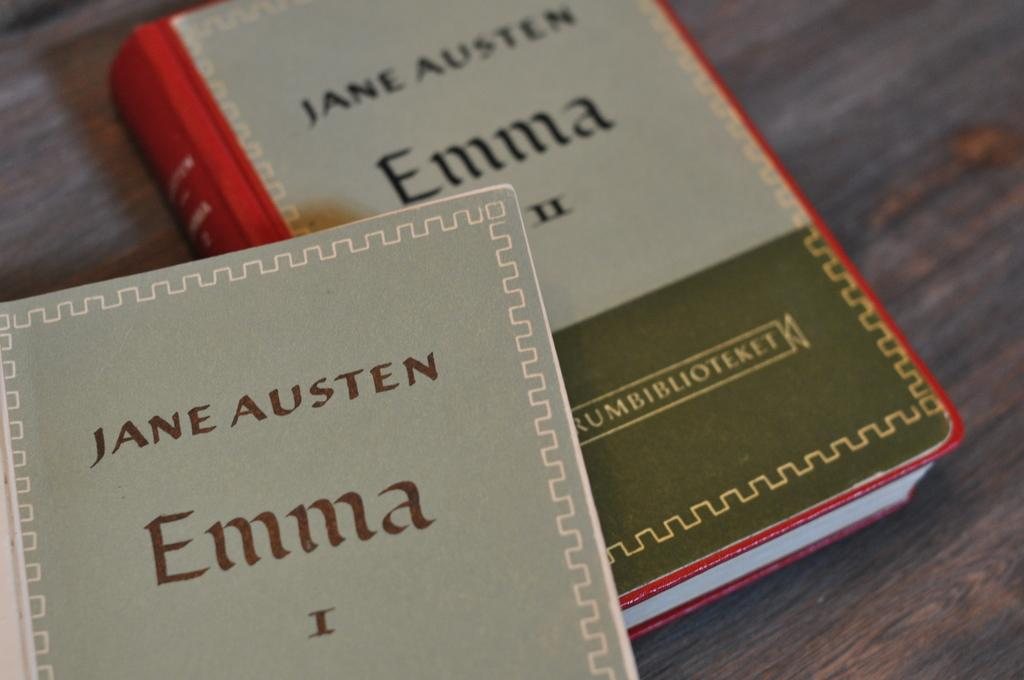<image>
Relay a brief, clear account of the picture shown. The book is entitled Emma and is written by Jane Austen. 